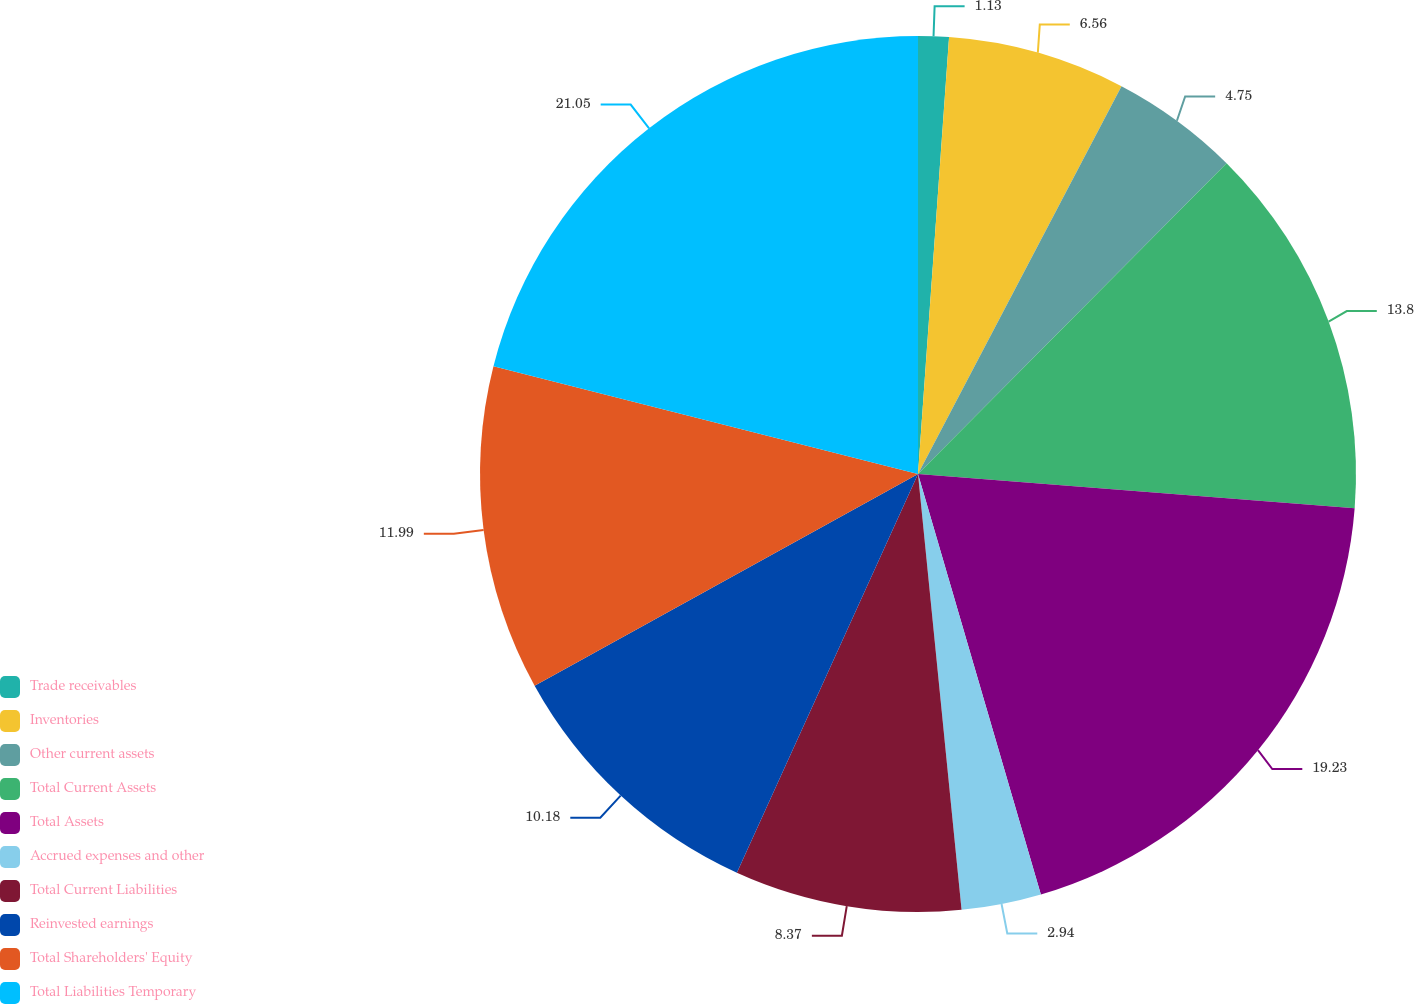Convert chart to OTSL. <chart><loc_0><loc_0><loc_500><loc_500><pie_chart><fcel>Trade receivables<fcel>Inventories<fcel>Other current assets<fcel>Total Current Assets<fcel>Total Assets<fcel>Accrued expenses and other<fcel>Total Current Liabilities<fcel>Reinvested earnings<fcel>Total Shareholders' Equity<fcel>Total Liabilities Temporary<nl><fcel>1.13%<fcel>6.56%<fcel>4.75%<fcel>13.8%<fcel>19.23%<fcel>2.94%<fcel>8.37%<fcel>10.18%<fcel>11.99%<fcel>21.04%<nl></chart> 